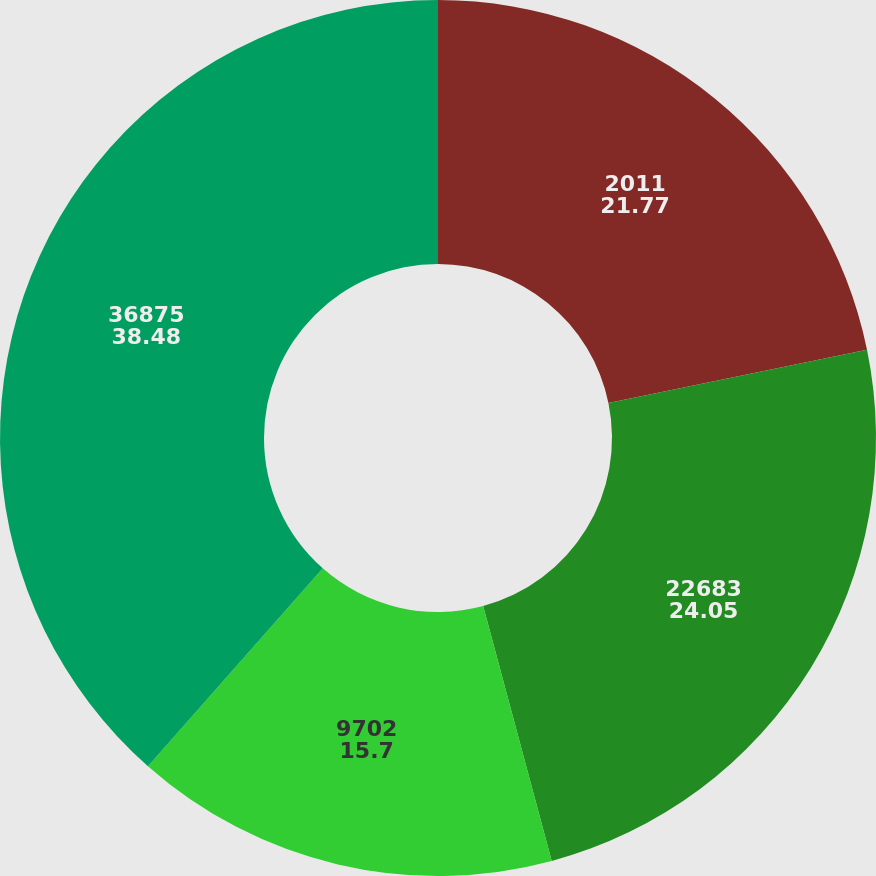Convert chart to OTSL. <chart><loc_0><loc_0><loc_500><loc_500><pie_chart><fcel>2011<fcel>22683<fcel>9702<fcel>36875<nl><fcel>21.77%<fcel>24.05%<fcel>15.7%<fcel>38.48%<nl></chart> 